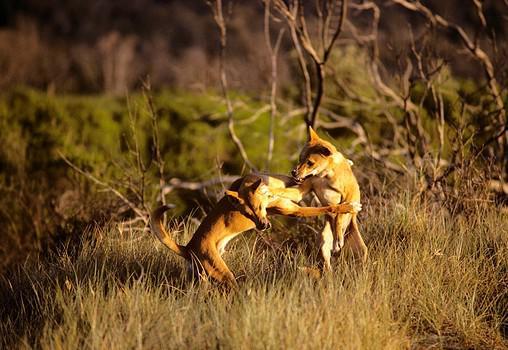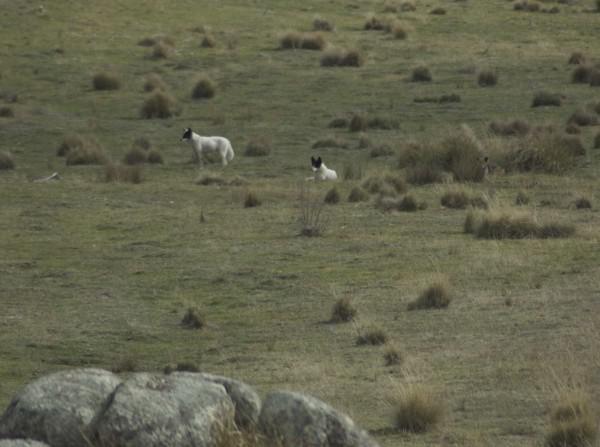The first image is the image on the left, the second image is the image on the right. Examine the images to the left and right. Is the description "A kangaroo is being attacked by two coyotes." accurate? Answer yes or no. No. The first image is the image on the left, the second image is the image on the right. Evaluate the accuracy of this statement regarding the images: "An upright kangaroo is flanked by two attacking dingos in the image on the left.". Is it true? Answer yes or no. No. 